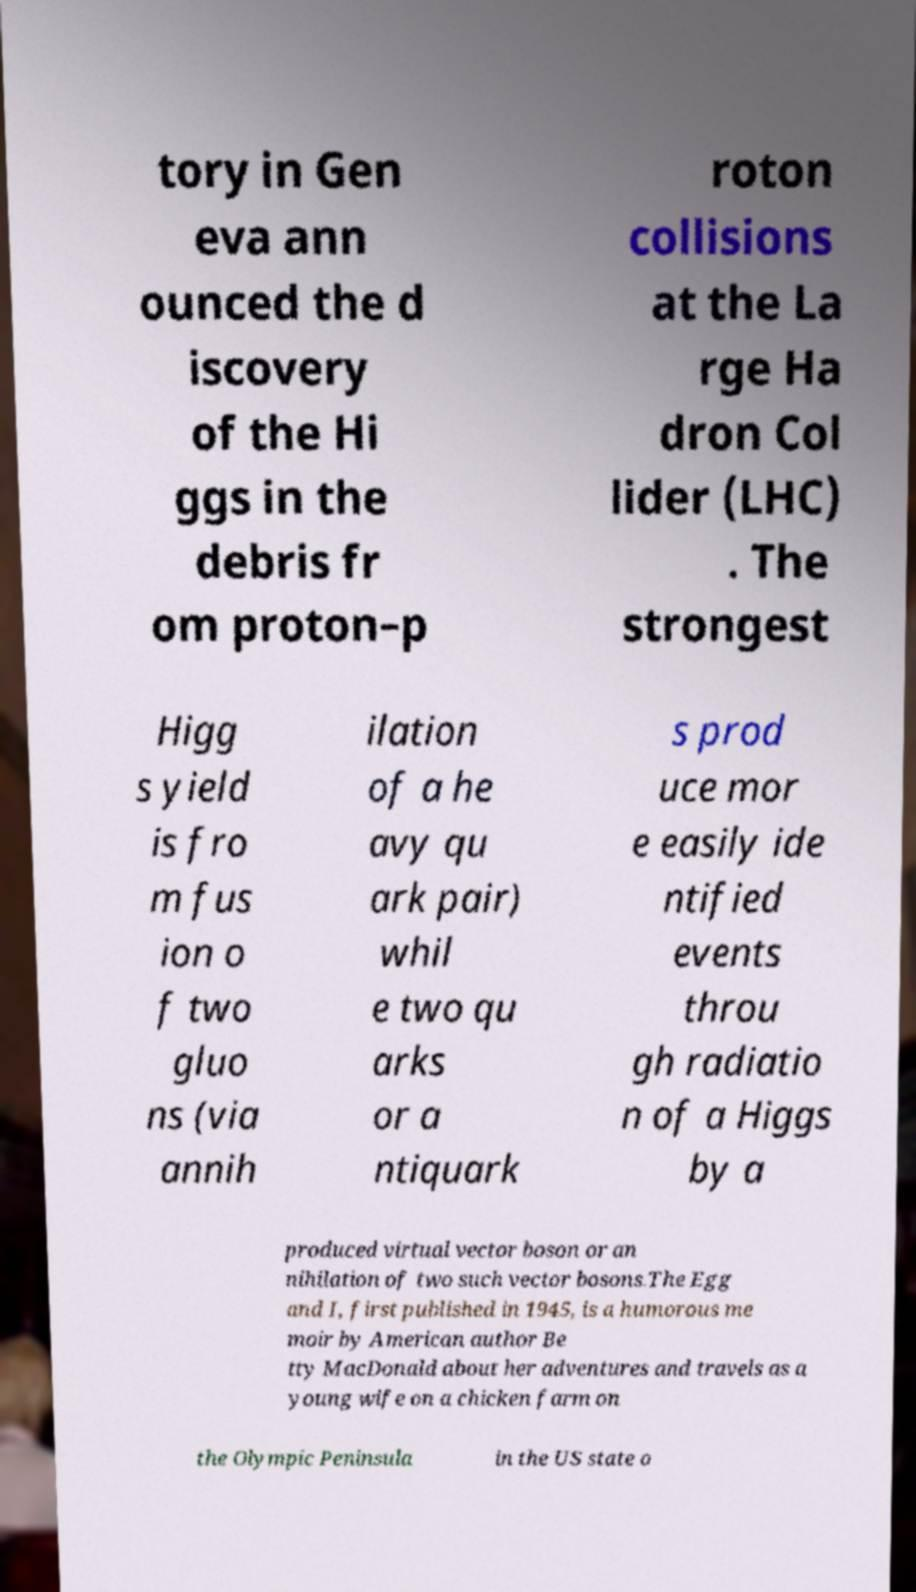Please identify and transcribe the text found in this image. tory in Gen eva ann ounced the d iscovery of the Hi ggs in the debris fr om proton–p roton collisions at the La rge Ha dron Col lider (LHC) . The strongest Higg s yield is fro m fus ion o f two gluo ns (via annih ilation of a he avy qu ark pair) whil e two qu arks or a ntiquark s prod uce mor e easily ide ntified events throu gh radiatio n of a Higgs by a produced virtual vector boson or an nihilation of two such vector bosons.The Egg and I, first published in 1945, is a humorous me moir by American author Be tty MacDonald about her adventures and travels as a young wife on a chicken farm on the Olympic Peninsula in the US state o 